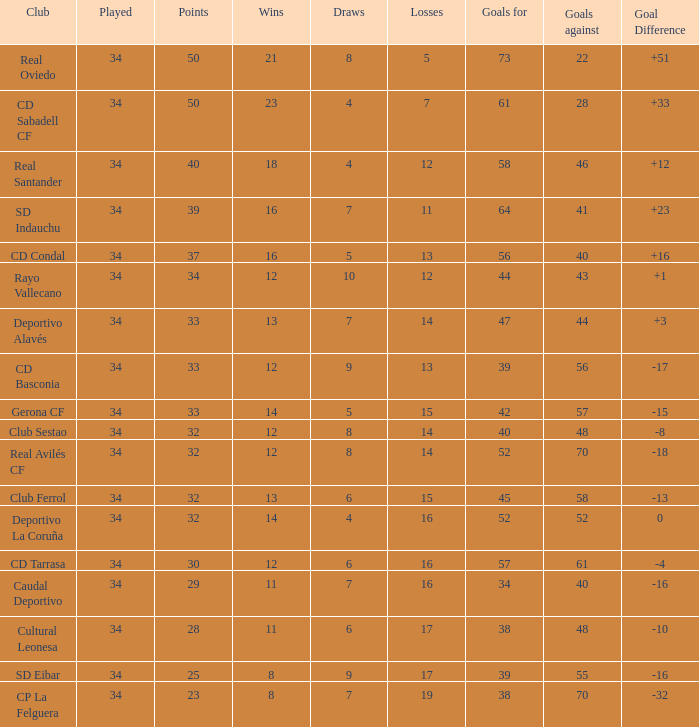Which Played has Draws smaller than 7, and Goals for smaller than 61, and Goals against smaller than 48, and a Position of 5? 34.0. 